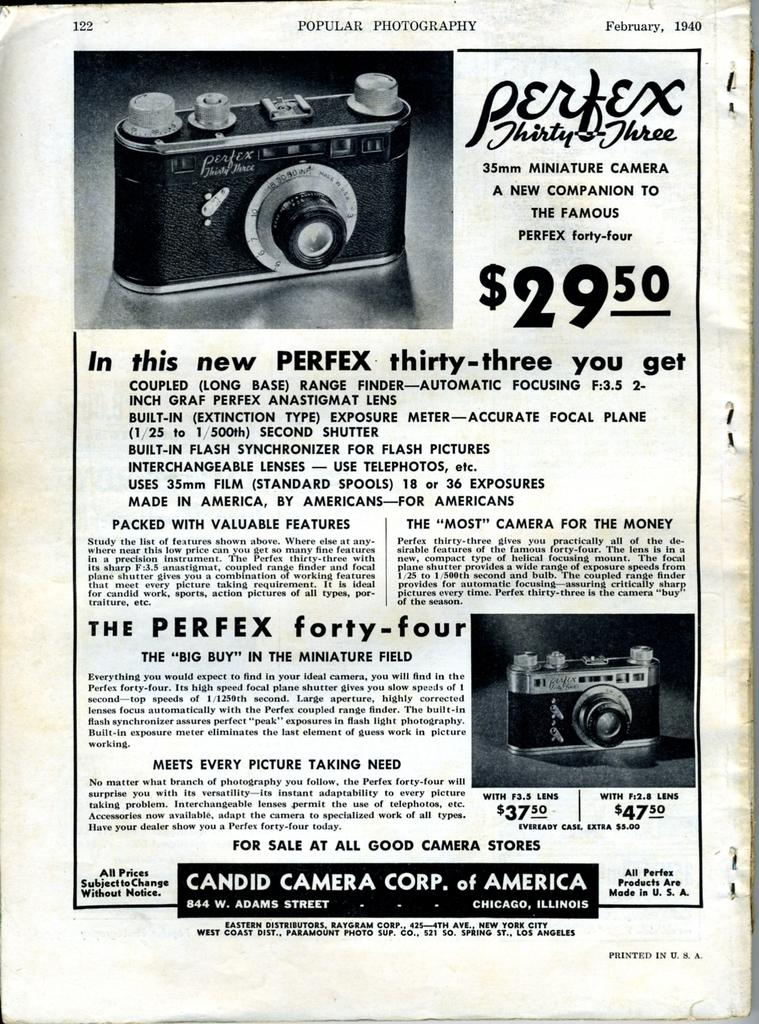What is featured in the image? There is a poster in the image. What can be found on the poster? The poster contains text and two images of a camera. What type of oatmeal is being advertised on the poster? There is no oatmeal present on the poster; it features text and images of a camera. 